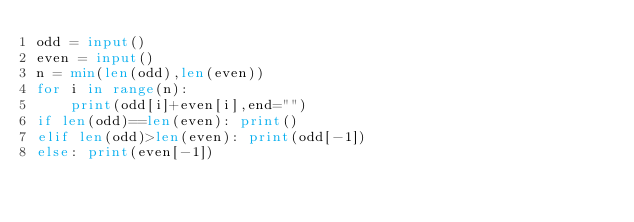Convert code to text. <code><loc_0><loc_0><loc_500><loc_500><_Python_>odd = input()
even = input()
n = min(len(odd),len(even))
for i in range(n):
    print(odd[i]+even[i],end="")
if len(odd)==len(even): print()
elif len(odd)>len(even): print(odd[-1])
else: print(even[-1])</code> 